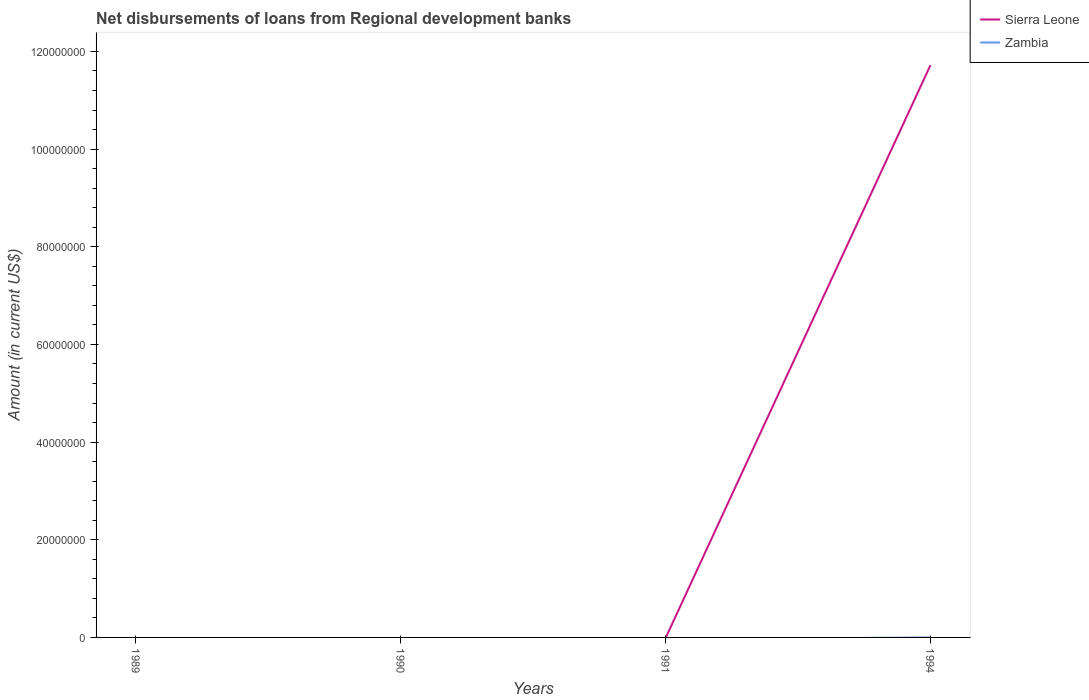How many different coloured lines are there?
Ensure brevity in your answer.  1. Does the line corresponding to Zambia intersect with the line corresponding to Sierra Leone?
Ensure brevity in your answer.  No. What is the difference between the highest and the second highest amount of disbursements of loans from regional development banks in Sierra Leone?
Give a very brief answer. 1.17e+08. What is the difference between the highest and the lowest amount of disbursements of loans from regional development banks in Zambia?
Ensure brevity in your answer.  0. Is the amount of disbursements of loans from regional development banks in Sierra Leone strictly greater than the amount of disbursements of loans from regional development banks in Zambia over the years?
Offer a very short reply. No. How many lines are there?
Give a very brief answer. 1. Are the values on the major ticks of Y-axis written in scientific E-notation?
Offer a terse response. No. How many legend labels are there?
Keep it short and to the point. 2. What is the title of the graph?
Your answer should be very brief. Net disbursements of loans from Regional development banks. Does "China" appear as one of the legend labels in the graph?
Your answer should be compact. No. What is the label or title of the X-axis?
Give a very brief answer. Years. What is the label or title of the Y-axis?
Offer a very short reply. Amount (in current US$). What is the Amount (in current US$) in Sierra Leone in 1991?
Ensure brevity in your answer.  0. What is the Amount (in current US$) in Sierra Leone in 1994?
Offer a terse response. 1.17e+08. Across all years, what is the maximum Amount (in current US$) in Sierra Leone?
Make the answer very short. 1.17e+08. What is the total Amount (in current US$) of Sierra Leone in the graph?
Provide a succinct answer. 1.17e+08. What is the total Amount (in current US$) of Zambia in the graph?
Your response must be concise. 0. What is the average Amount (in current US$) in Sierra Leone per year?
Your answer should be very brief. 2.93e+07. What is the difference between the highest and the lowest Amount (in current US$) of Sierra Leone?
Offer a very short reply. 1.17e+08. 